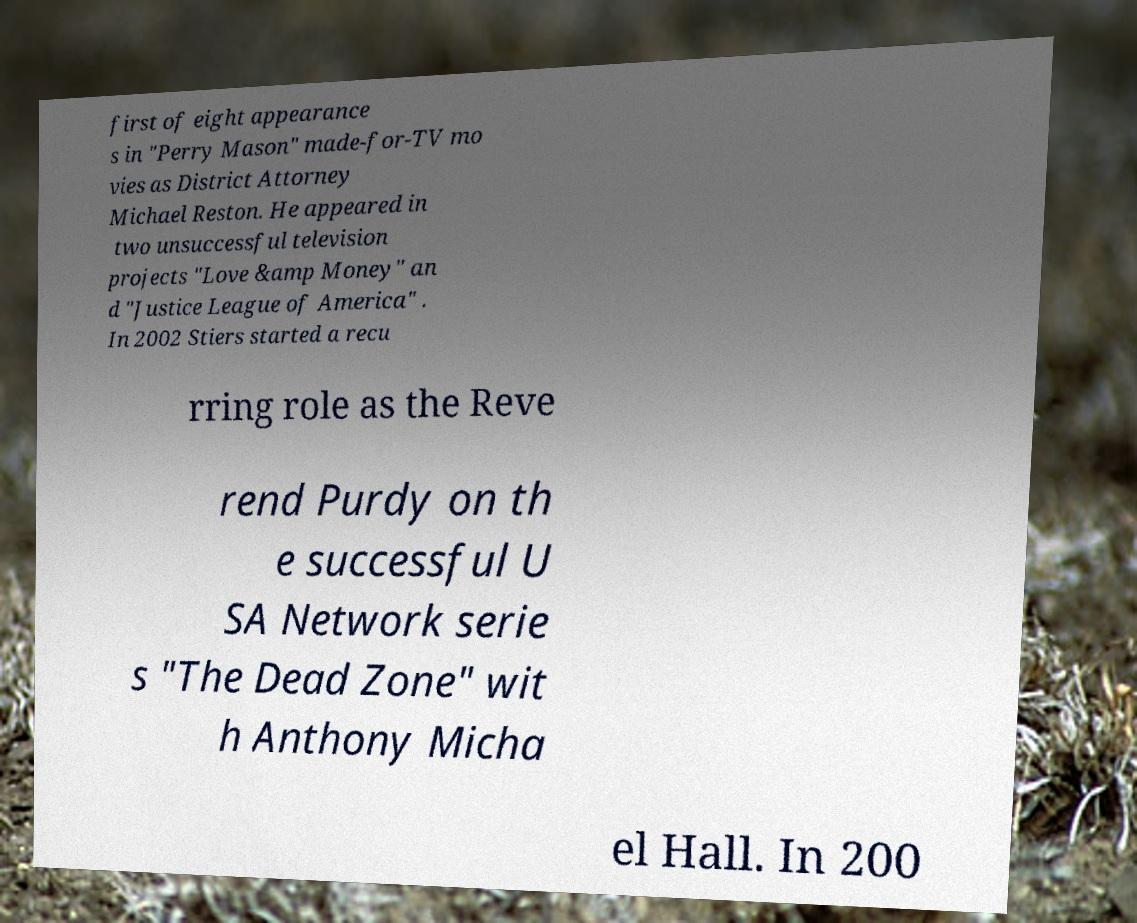What messages or text are displayed in this image? I need them in a readable, typed format. first of eight appearance s in "Perry Mason" made-for-TV mo vies as District Attorney Michael Reston. He appeared in two unsuccessful television projects "Love &amp Money" an d "Justice League of America" . In 2002 Stiers started a recu rring role as the Reve rend Purdy on th e successful U SA Network serie s "The Dead Zone" wit h Anthony Micha el Hall. In 200 